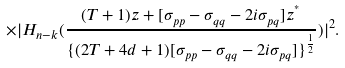Convert formula to latex. <formula><loc_0><loc_0><loc_500><loc_500>\times | H _ { n - k } ( \frac { ( T + 1 ) z + [ \sigma _ { p p } - \sigma _ { q q } - 2 i \sigma _ { p q } ] z ^ { ^ { * } } } { \{ ( 2 T + 4 d + 1 ) [ \sigma _ { p p } - \sigma _ { q q } - 2 i \sigma _ { p q } ] \} ^ { \frac { 1 } { 2 } } } ) | ^ { 2 } .</formula> 